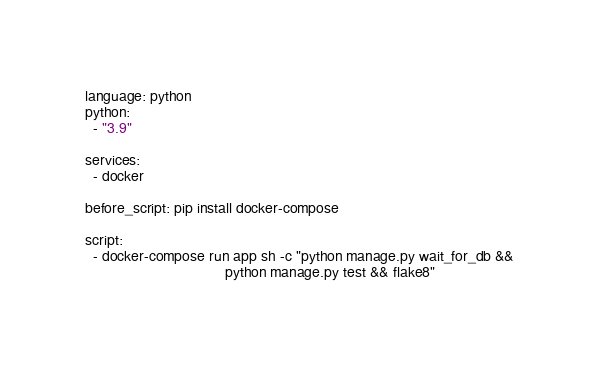<code> <loc_0><loc_0><loc_500><loc_500><_YAML_>language: python
python: 
  - "3.9"
 
services: 
  - docker
  
before_script: pip install docker-compose

script: 
  - docker-compose run app sh -c "python manage.py wait_for_db && 
                                  python manage.py test && flake8"
  </code> 